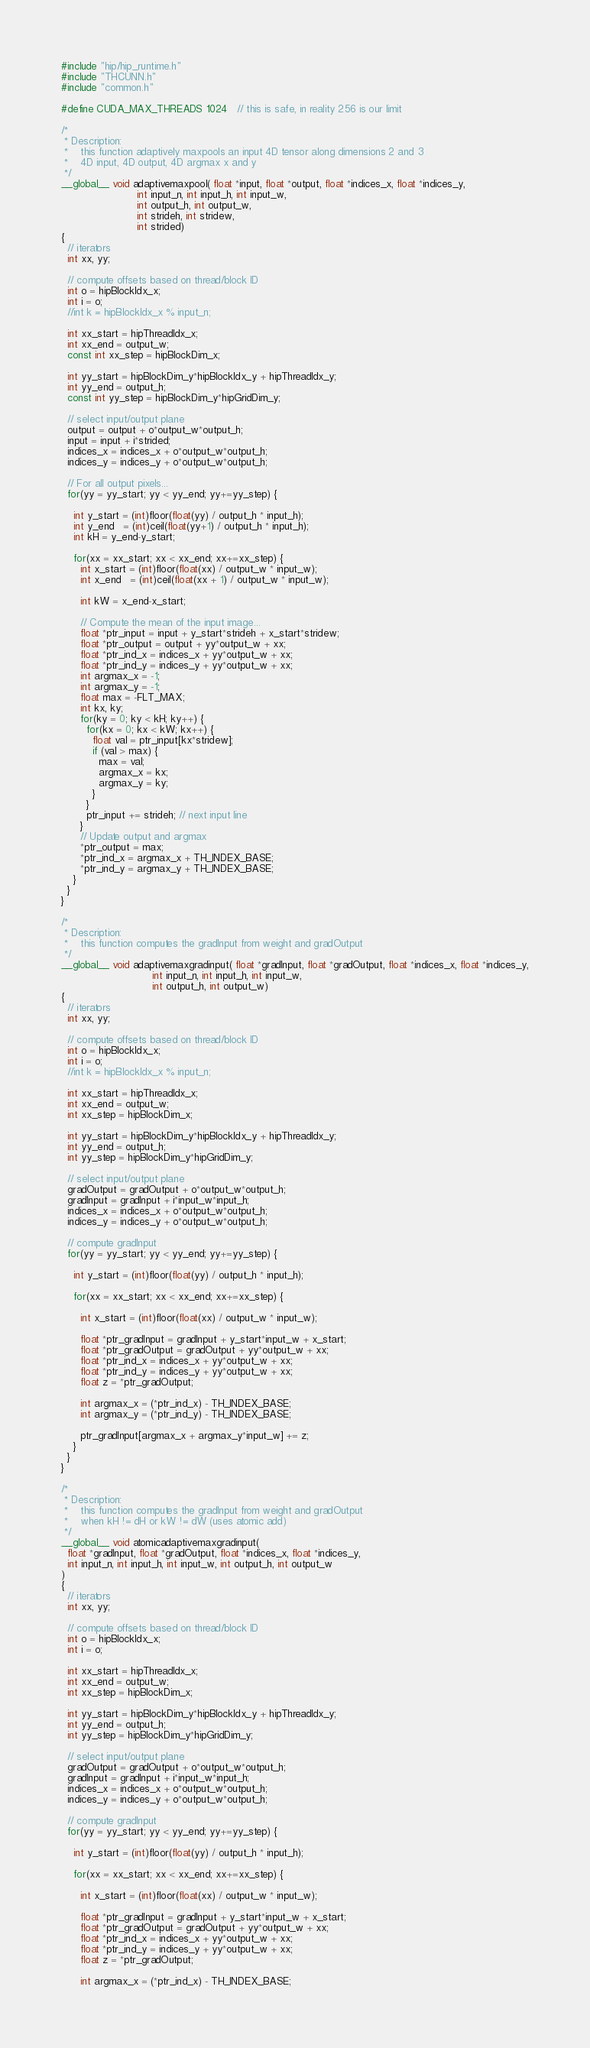<code> <loc_0><loc_0><loc_500><loc_500><_Cuda_>#include "hip/hip_runtime.h"
#include "THCUNN.h"
#include "common.h"

#define CUDA_MAX_THREADS 1024   // this is safe, in reality 256 is our limit

/*
 * Description:
 *    this function adaptively maxpools an input 4D tensor along dimensions 2 and 3
 *    4D input, 4D output, 4D argmax x and y
 */
__global__ void adaptivemaxpool( float *input, float *output, float *indices_x, float *indices_y,
                        int input_n, int input_h, int input_w,
                        int output_h, int output_w,
                        int strideh, int stridew,
                        int strided)
{
  // iterators
  int xx, yy;

  // compute offsets based on thread/block ID
  int o = hipBlockIdx_x;
  int i = o;
  //int k = hipBlockIdx_x % input_n;

  int xx_start = hipThreadIdx_x;
  int xx_end = output_w;
  const int xx_step = hipBlockDim_x;

  int yy_start = hipBlockDim_y*hipBlockIdx_y + hipThreadIdx_y;
  int yy_end = output_h;
  const int yy_step = hipBlockDim_y*hipGridDim_y;

  // select input/output plane
  output = output + o*output_w*output_h;
  input = input + i*strided;
  indices_x = indices_x + o*output_w*output_h;
  indices_y = indices_y + o*output_w*output_h;

  // For all output pixels...
  for(yy = yy_start; yy < yy_end; yy+=yy_step) {

    int y_start = (int)floor(float(yy) / output_h * input_h);
    int y_end   = (int)ceil(float(yy+1) / output_h * input_h);
    int kH = y_end-y_start;

    for(xx = xx_start; xx < xx_end; xx+=xx_step) {
      int x_start = (int)floor(float(xx) / output_w * input_w);
      int x_end   = (int)ceil(float(xx + 1) / output_w * input_w);

      int kW = x_end-x_start;

      // Compute the mean of the input image...
      float *ptr_input = input + y_start*strideh + x_start*stridew;
      float *ptr_output = output + yy*output_w + xx;
      float *ptr_ind_x = indices_x + yy*output_w + xx;
      float *ptr_ind_y = indices_y + yy*output_w + xx;
      int argmax_x = -1;
      int argmax_y = -1;
      float max = -FLT_MAX;
      int kx, ky;
      for(ky = 0; ky < kH; ky++) {
        for(kx = 0; kx < kW; kx++) {
          float val = ptr_input[kx*stridew];
          if (val > max) {
            max = val;
            argmax_x = kx;
            argmax_y = ky;
          }
        }
        ptr_input += strideh; // next input line
      }
      // Update output and argmax
      *ptr_output = max;
      *ptr_ind_x = argmax_x + TH_INDEX_BASE;
      *ptr_ind_y = argmax_y + TH_INDEX_BASE;
    }
  }
}

/*
 * Description:
 *    this function computes the gradInput from weight and gradOutput
 */
__global__ void adaptivemaxgradinput( float *gradInput, float *gradOutput, float *indices_x, float *indices_y,
                             int input_n, int input_h, int input_w,
                             int output_h, int output_w)
{
  // iterators
  int xx, yy;

  // compute offsets based on thread/block ID
  int o = hipBlockIdx_x;
  int i = o;
  //int k = hipBlockIdx_x % input_n;

  int xx_start = hipThreadIdx_x;
  int xx_end = output_w;
  int xx_step = hipBlockDim_x;

  int yy_start = hipBlockDim_y*hipBlockIdx_y + hipThreadIdx_y;
  int yy_end = output_h;
  int yy_step = hipBlockDim_y*hipGridDim_y;

  // select input/output plane
  gradOutput = gradOutput + o*output_w*output_h;
  gradInput = gradInput + i*input_w*input_h;
  indices_x = indices_x + o*output_w*output_h;
  indices_y = indices_y + o*output_w*output_h;

  // compute gradInput
  for(yy = yy_start; yy < yy_end; yy+=yy_step) {

    int y_start = (int)floor(float(yy) / output_h * input_h);

    for(xx = xx_start; xx < xx_end; xx+=xx_step) {

      int x_start = (int)floor(float(xx) / output_w * input_w);

      float *ptr_gradInput = gradInput + y_start*input_w + x_start;
      float *ptr_gradOutput = gradOutput + yy*output_w + xx;
      float *ptr_ind_x = indices_x + yy*output_w + xx;
      float *ptr_ind_y = indices_y + yy*output_w + xx;
      float z = *ptr_gradOutput;

      int argmax_x = (*ptr_ind_x) - TH_INDEX_BASE;
      int argmax_y = (*ptr_ind_y) - TH_INDEX_BASE;

      ptr_gradInput[argmax_x + argmax_y*input_w] += z;
    }
  }
}

/*
 * Description:
 *    this function computes the gradInput from weight and gradOutput
 *    when kH != dH or kW != dW (uses atomic add)
 */
__global__ void atomicadaptivemaxgradinput( 
  float *gradInput, float *gradOutput, float *indices_x, float *indices_y,
  int input_n, int input_h, int input_w, int output_h, int output_w
)
{
  // iterators
  int xx, yy;

  // compute offsets based on thread/block ID
  int o = hipBlockIdx_x;
  int i = o;

  int xx_start = hipThreadIdx_x;
  int xx_end = output_w;
  int xx_step = hipBlockDim_x;

  int yy_start = hipBlockDim_y*hipBlockIdx_y + hipThreadIdx_y;
  int yy_end = output_h;
  int yy_step = hipBlockDim_y*hipGridDim_y;

  // select input/output plane
  gradOutput = gradOutput + o*output_w*output_h;
  gradInput = gradInput + i*input_w*input_h;
  indices_x = indices_x + o*output_w*output_h;
  indices_y = indices_y + o*output_w*output_h;

  // compute gradInput
  for(yy = yy_start; yy < yy_end; yy+=yy_step) {

    int y_start = (int)floor(float(yy) / output_h * input_h);

    for(xx = xx_start; xx < xx_end; xx+=xx_step) {

      int x_start = (int)floor(float(xx) / output_w * input_w);

      float *ptr_gradInput = gradInput + y_start*input_w + x_start;
      float *ptr_gradOutput = gradOutput + yy*output_w + xx;
      float *ptr_ind_x = indices_x + yy*output_w + xx;
      float *ptr_ind_y = indices_y + yy*output_w + xx;
      float z = *ptr_gradOutput;

      int argmax_x = (*ptr_ind_x) - TH_INDEX_BASE;</code> 